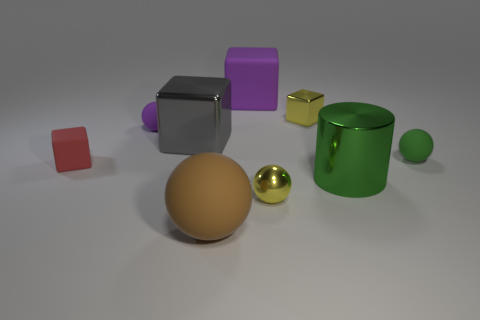Is there any other thing that is the same shape as the large green shiny thing?
Provide a succinct answer. No. Is the material of the tiny yellow thing in front of the green rubber sphere the same as the thing that is right of the big green cylinder?
Offer a terse response. No. There is a large matte thing that is behind the tiny rubber thing right of the yellow shiny sphere; what is its shape?
Your answer should be very brief. Cube. There is a big ball that is the same material as the small red cube; what color is it?
Offer a very short reply. Brown. Do the shiny sphere and the tiny metal block have the same color?
Your response must be concise. Yes. There is a gray thing that is the same size as the purple block; what is its shape?
Your answer should be compact. Cube. How big is the green matte thing?
Your answer should be compact. Small. Is the size of the green object that is right of the cylinder the same as the shiny block on the right side of the large gray shiny cube?
Provide a succinct answer. Yes. The tiny block that is to the left of the tiny yellow object that is in front of the tiny yellow shiny block is what color?
Offer a terse response. Red. What is the material of the yellow block that is the same size as the yellow metal ball?
Keep it short and to the point. Metal. 